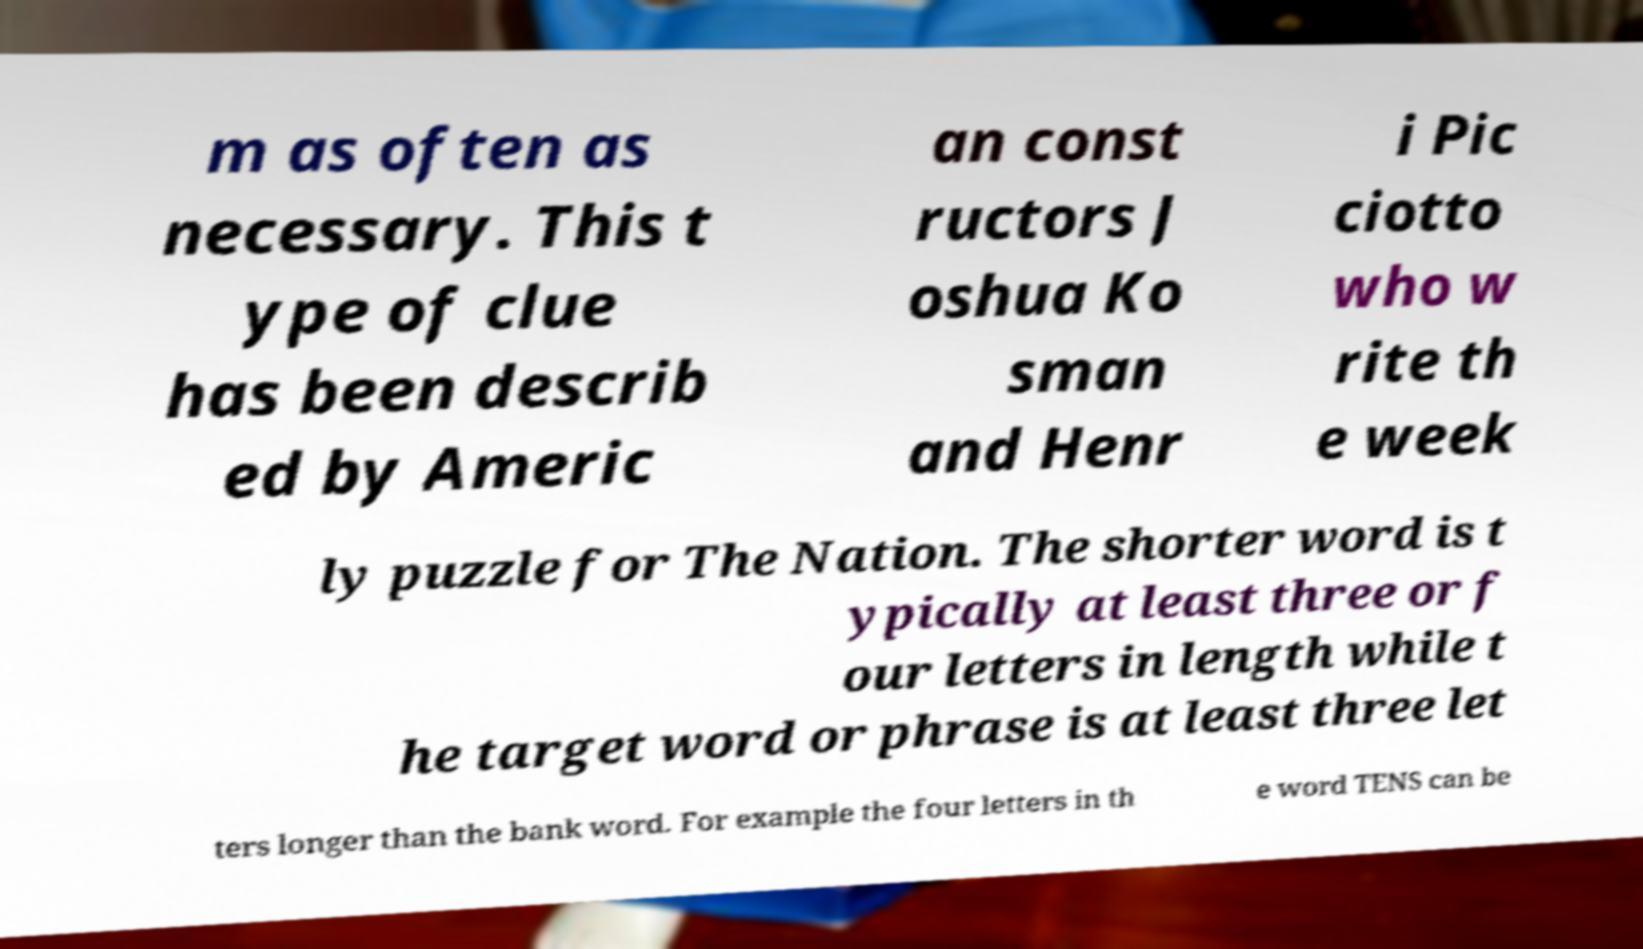For documentation purposes, I need the text within this image transcribed. Could you provide that? m as often as necessary. This t ype of clue has been describ ed by Americ an const ructors J oshua Ko sman and Henr i Pic ciotto who w rite th e week ly puzzle for The Nation. The shorter word is t ypically at least three or f our letters in length while t he target word or phrase is at least three let ters longer than the bank word. For example the four letters in th e word TENS can be 